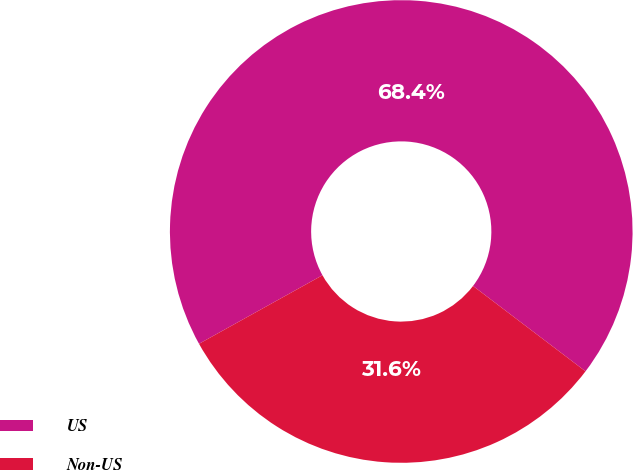<chart> <loc_0><loc_0><loc_500><loc_500><pie_chart><fcel>US<fcel>Non-US<nl><fcel>68.4%<fcel>31.6%<nl></chart> 